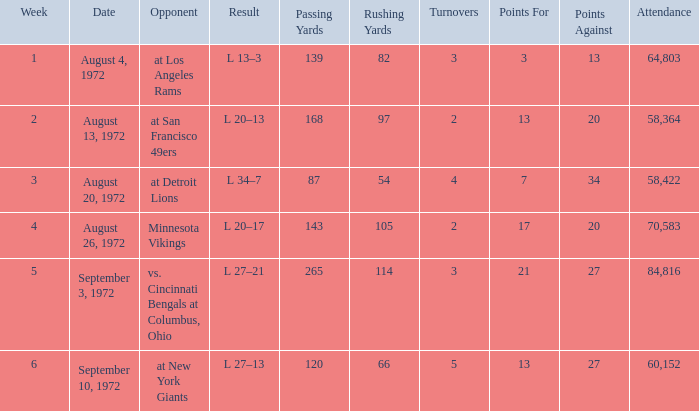How many weeks had an attendance larger than 84,816? 0.0. 